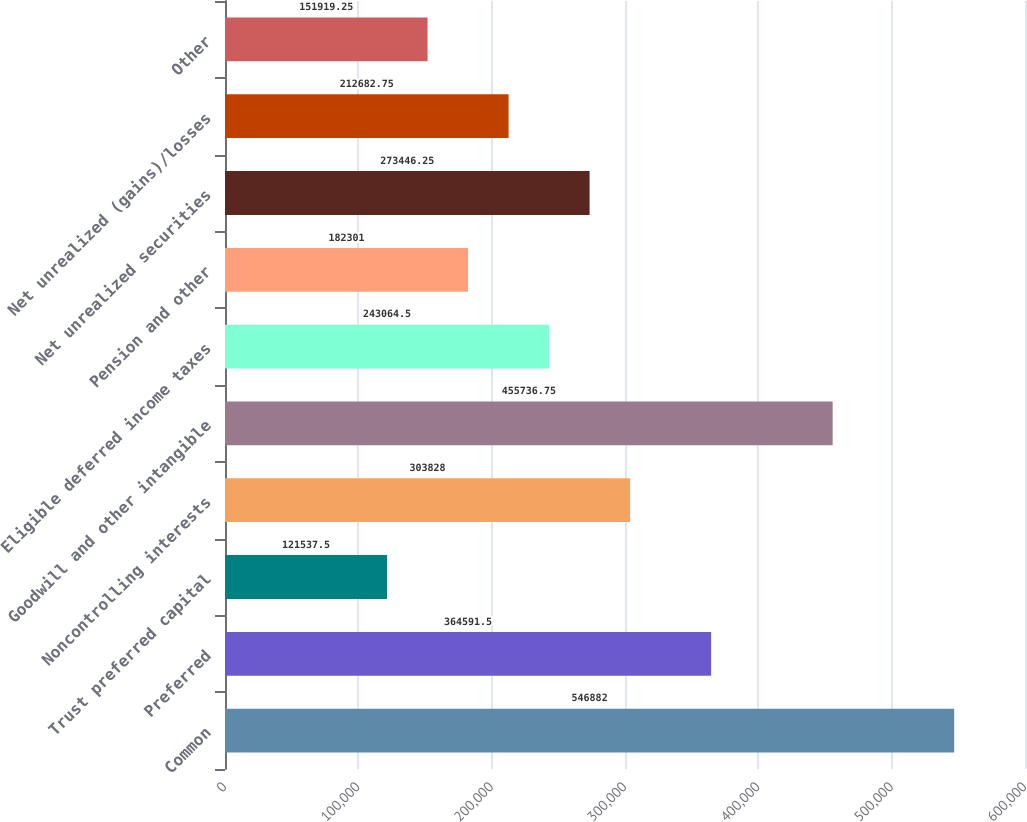Convert chart to OTSL. <chart><loc_0><loc_0><loc_500><loc_500><bar_chart><fcel>Common<fcel>Preferred<fcel>Trust preferred capital<fcel>Noncontrolling interests<fcel>Goodwill and other intangible<fcel>Eligible deferred income taxes<fcel>Pension and other<fcel>Net unrealized securities<fcel>Net unrealized (gains)/losses<fcel>Other<nl><fcel>546882<fcel>364592<fcel>121538<fcel>303828<fcel>455737<fcel>243064<fcel>182301<fcel>273446<fcel>212683<fcel>151919<nl></chart> 